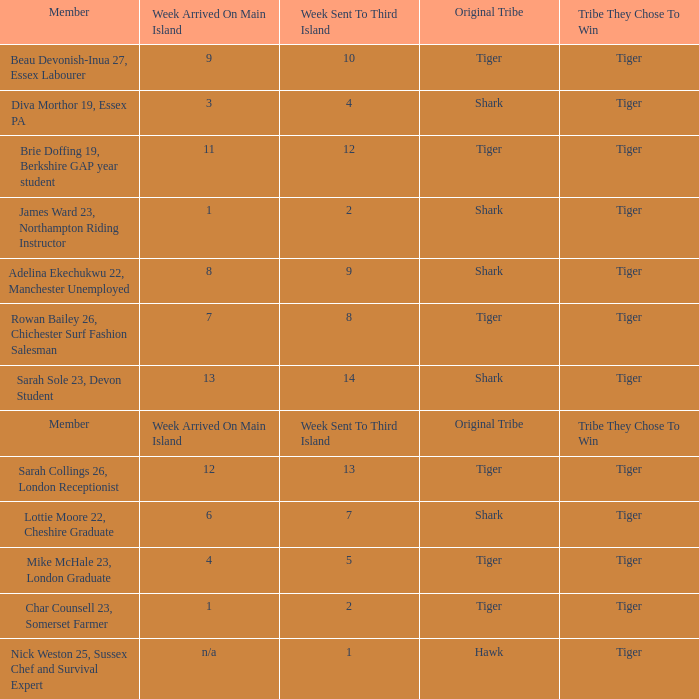What week did the member who's original tribe was shark and who was sent to the third island on week 14 arrive on the main island? 13.0. 